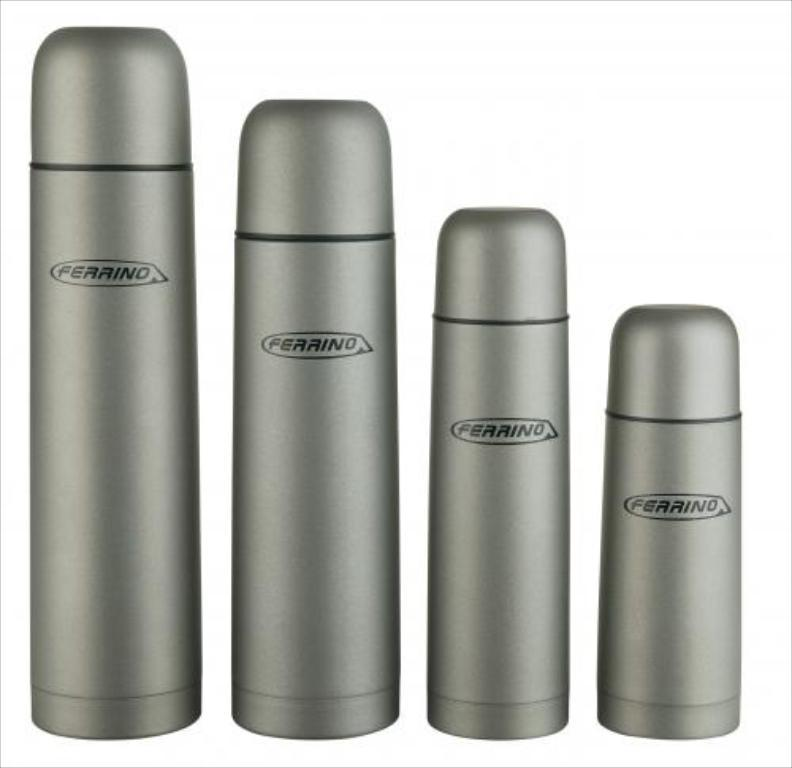<image>
Describe the image concisely. A row of Ferrino thermoses lined up in order of size. 